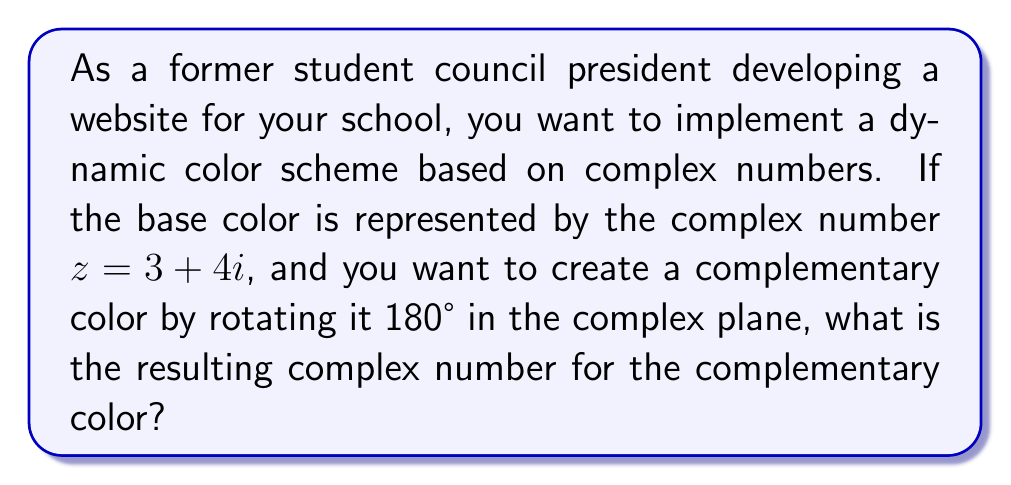Solve this math problem. To solve this problem, we'll follow these steps:

1) The complex number $z = 3 + 4i$ can be represented in polar form as $r(\cos\theta + i\sin\theta)$, where $r$ is the magnitude and $\theta$ is the argument.

2) Calculate the magnitude:
   $$r = \sqrt{3^2 + 4^2} = \sqrt{25} = 5$$

3) Calculate the argument:
   $$\theta = \arctan(\frac{4}{3}) \approx 0.9273 \text{ radians}$$

4) To rotate by 180°, we add $\pi$ radians to the argument:
   $$\theta_{new} = \theta + \pi \approx 0.9273 + 3.1416 \approx 4.0689 \text{ radians}$$

5) The new complex number in polar form is:
   $$5(\cos(4.0689) + i\sin(4.0689))$$

6) Convert back to rectangular form:
   $$x = 5\cos(4.0689) \approx -3$$
   $$y = 5\sin(4.0689) \approx -4$$

Therefore, the complementary color is represented by the complex number $-3 - 4i$.
Answer: $-3 - 4i$ 